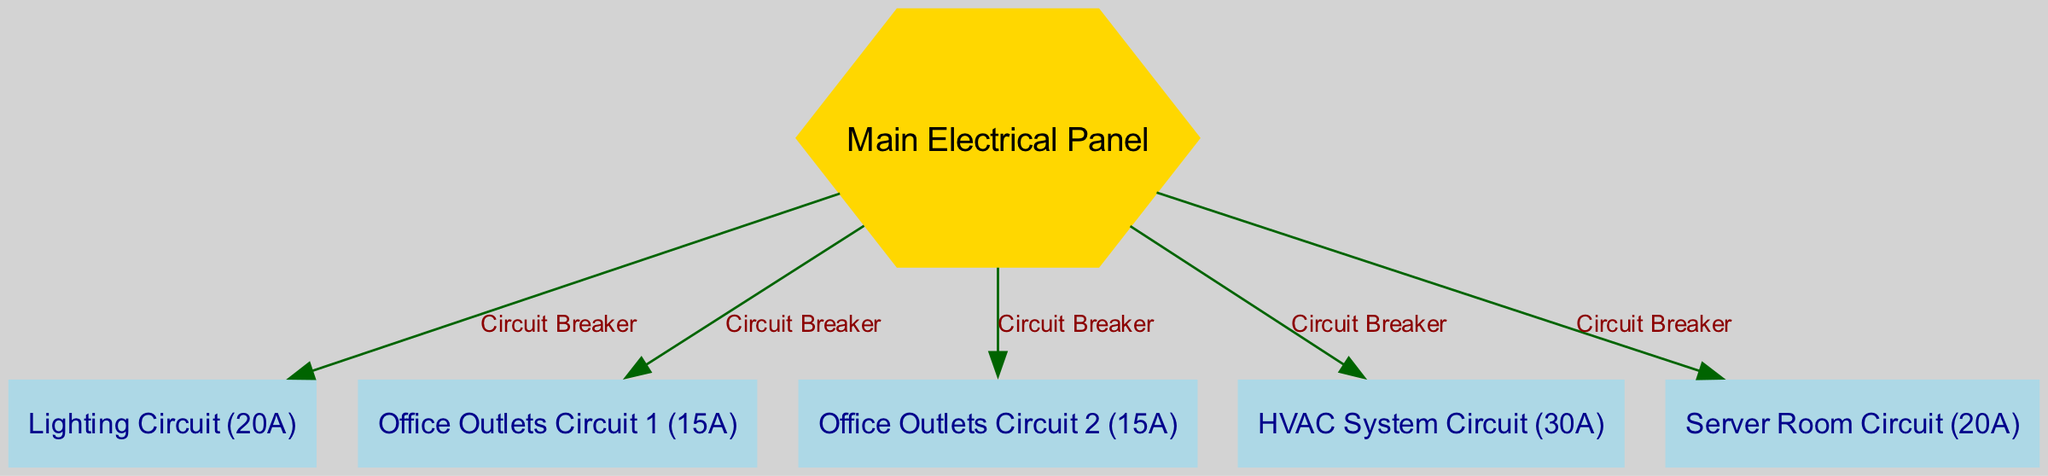What is the total number of circuit breakers connected to the main panel? The main panel has five outgoing connections, each representing a circuit breaker for different circuits. By counting the edges from the main panel in the diagram, we confirm that there are five circuit breakers.
Answer: 5 What is the amperage rating of the HVAC system circuit? The HVAC system circuit node is labeled with a rating of 30A. This information is directly visible on the node representing the HVAC circuit.
Answer: 30A What type of node is the main electrical panel? The main electrical panel node is represented as a hexagon in the diagram as it is specified to have a unique shape compared to the other rectangular nodes.
Answer: Hexagon How many office outlet circuits are shown in the diagram? The diagram includes two dedicated nodes labeled as outlet circuit 1 and outlet circuit 2, indicating there are two separate office outlet circuits.
Answer: 2 What do all the edges from the main panel represent? Every edge connecting from the main panel to other nodes indicates a circuit breaker connecting the main panel to a specific circuit for either lighting or outlets, each serving distinct areas.
Answer: Circuit Breaker Which circuit has the lowest amperage? Among all the circuits displayed, both the office outlets circuit 1 and outlet circuit 2 are both rated at 15A, which is the lowest amperage compared to the other circuits shown.
Answer: 15A Is the server room circuit more powerful than the lighting circuit? The server room circuit is rated at 20A while the lighting circuit is rated at 20A, making them equal in capacity. Thus, the server room circuit is not more powerful; they share the same amperage rating.
Answer: No Which node is the only one colored gold in the diagram? The main electrical panel is uniquely colored gold, differentiating it from other nodes in the diagram that are colored light blue. This distinction highlights its importance as the main source of power distribution.
Answer: Main Electrical Panel 